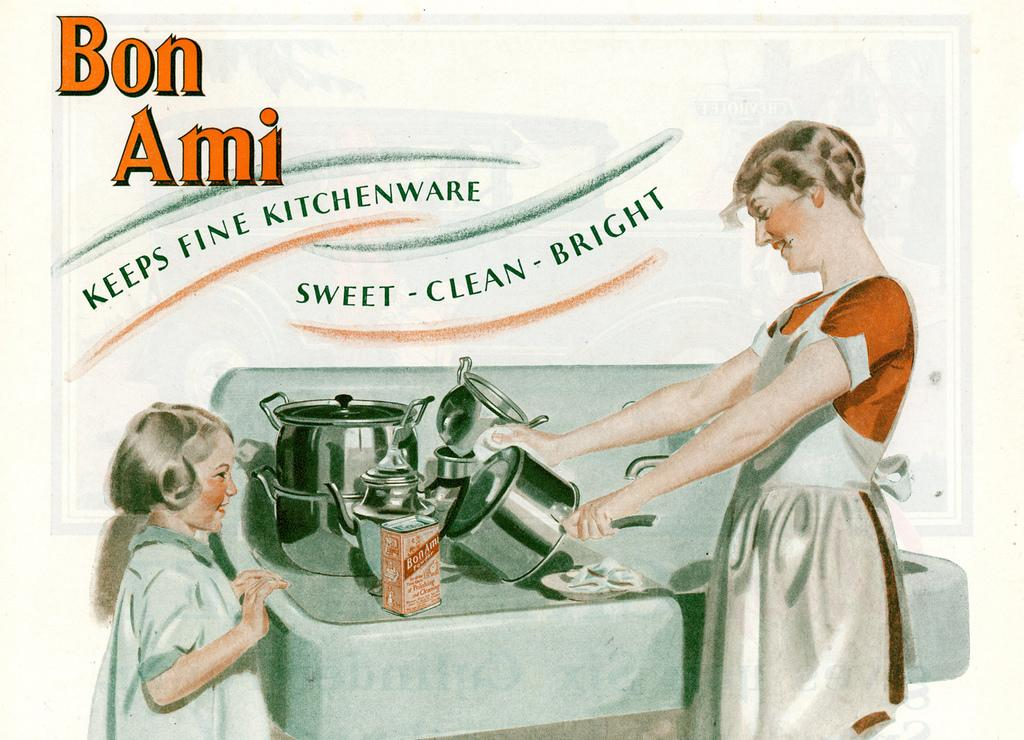What is the main subject of the painting or banner in the image? The painting depicts a small girl and a lady holding utensils. Can you describe the scene in the painting? The painting shows a small girl and a lady holding utensils, and there are utensils on a table in the painting. How much steam is coming off the utensils in the painting? There is no steam present in the painting; it only depicts a small girl, a lady holding utensils, and utensils on a table. 